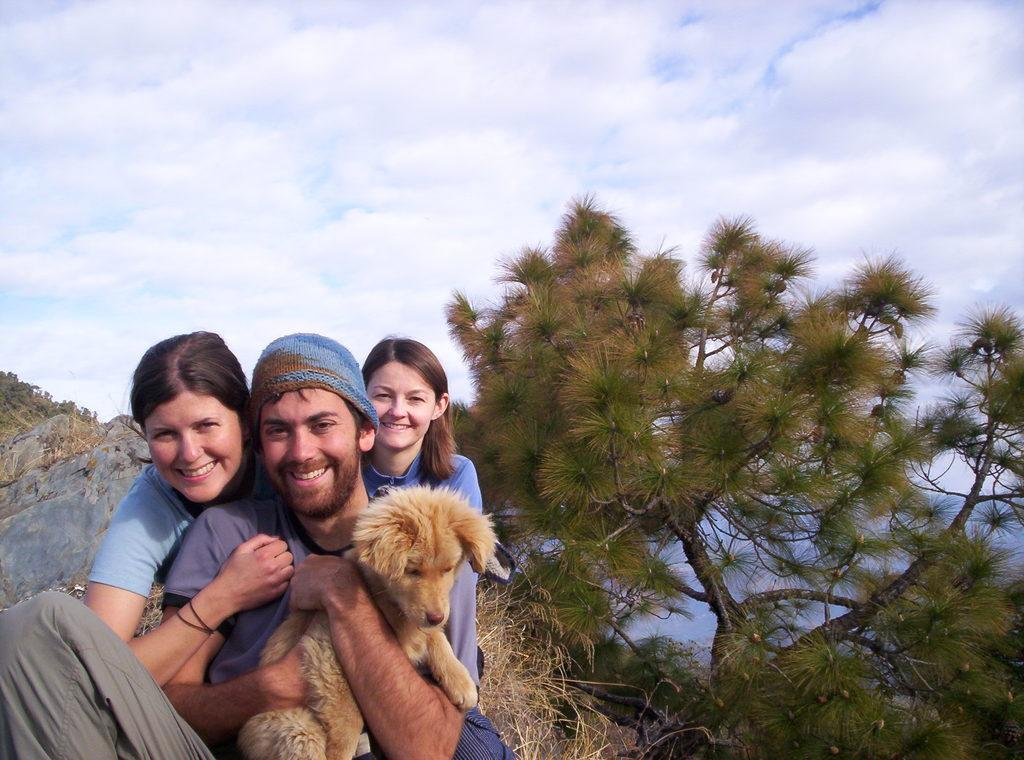What is the man in the image doing? The man is holding a dog in the image. How many people are present in the image? There are three people in the image: one man and two women. What is the emotional state of the people in the image? The man and the two women are smiling in the image. What can be seen in the background of the image? There are trees and the sky visible in the background of the image. What type of zephyr can be seen blowing through the trees in the image? There is no zephyr present in the image; it is a still image with no movement or wind. What is the temperature of the fire in the image? There is no fire present in the image. 